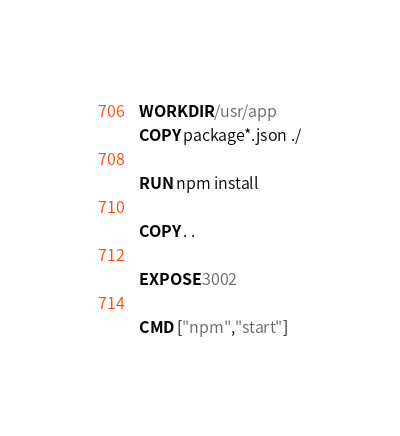<code> <loc_0><loc_0><loc_500><loc_500><_Dockerfile_>WORKDIR /usr/app
COPY package*.json ./

RUN npm install

COPY . .

EXPOSE 3002

CMD ["npm","start"]</code> 